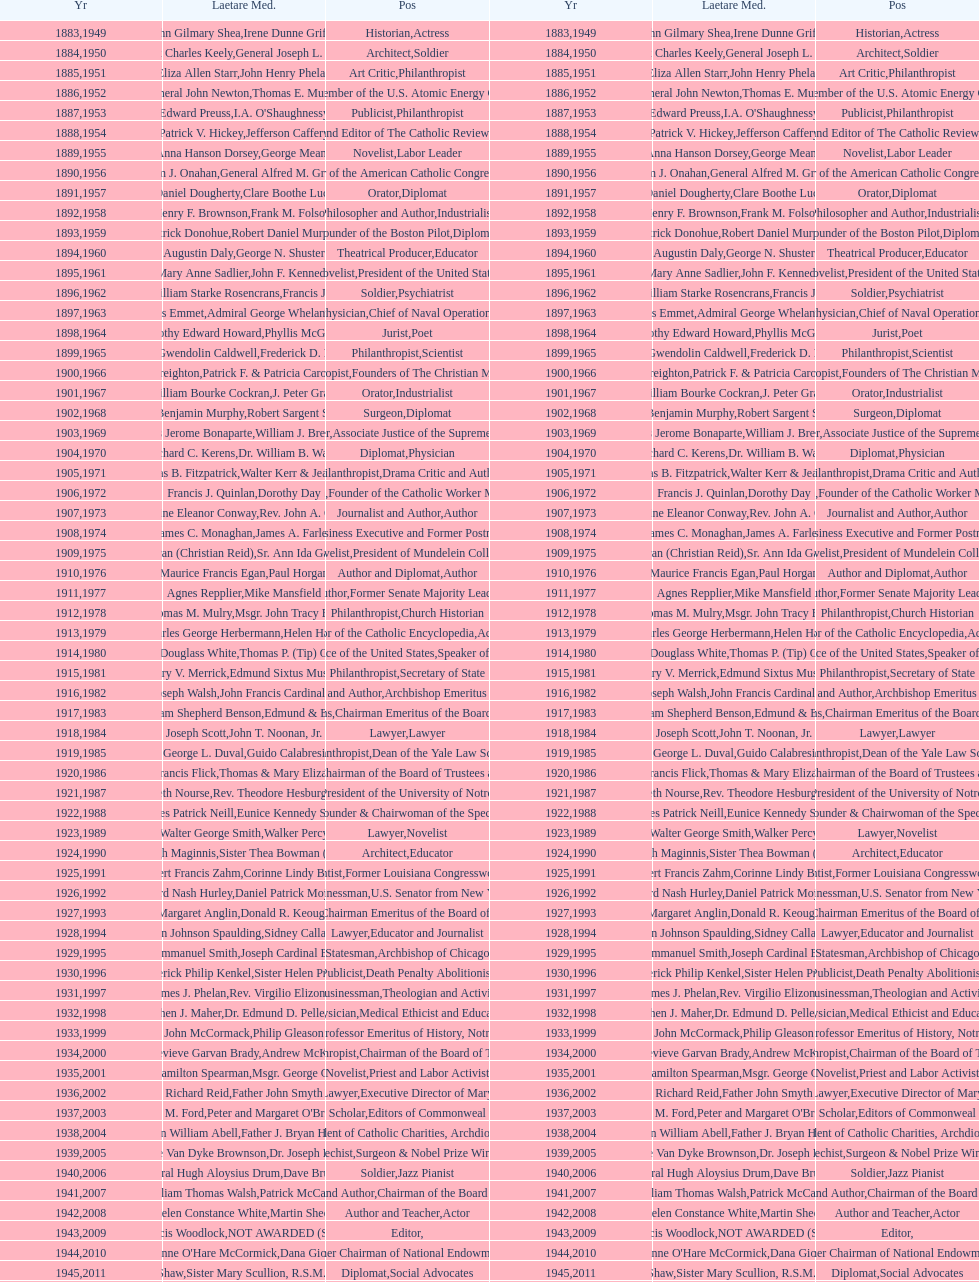What is the name of the laetare medalist listed before edward preuss? General John Newton. 